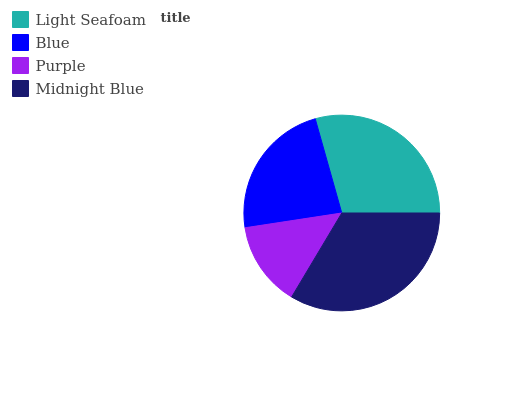Is Purple the minimum?
Answer yes or no. Yes. Is Midnight Blue the maximum?
Answer yes or no. Yes. Is Blue the minimum?
Answer yes or no. No. Is Blue the maximum?
Answer yes or no. No. Is Light Seafoam greater than Blue?
Answer yes or no. Yes. Is Blue less than Light Seafoam?
Answer yes or no. Yes. Is Blue greater than Light Seafoam?
Answer yes or no. No. Is Light Seafoam less than Blue?
Answer yes or no. No. Is Light Seafoam the high median?
Answer yes or no. Yes. Is Blue the low median?
Answer yes or no. Yes. Is Blue the high median?
Answer yes or no. No. Is Midnight Blue the low median?
Answer yes or no. No. 